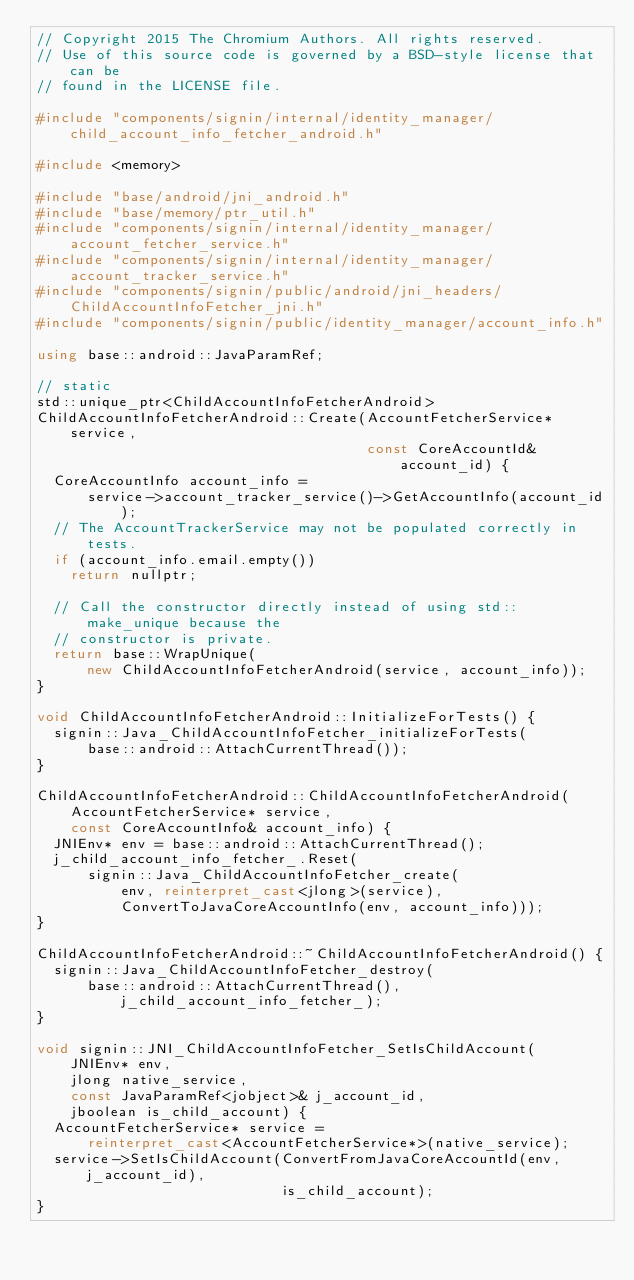<code> <loc_0><loc_0><loc_500><loc_500><_C++_>// Copyright 2015 The Chromium Authors. All rights reserved.
// Use of this source code is governed by a BSD-style license that can be
// found in the LICENSE file.

#include "components/signin/internal/identity_manager/child_account_info_fetcher_android.h"

#include <memory>

#include "base/android/jni_android.h"
#include "base/memory/ptr_util.h"
#include "components/signin/internal/identity_manager/account_fetcher_service.h"
#include "components/signin/internal/identity_manager/account_tracker_service.h"
#include "components/signin/public/android/jni_headers/ChildAccountInfoFetcher_jni.h"
#include "components/signin/public/identity_manager/account_info.h"

using base::android::JavaParamRef;

// static
std::unique_ptr<ChildAccountInfoFetcherAndroid>
ChildAccountInfoFetcherAndroid::Create(AccountFetcherService* service,
                                       const CoreAccountId& account_id) {
  CoreAccountInfo account_info =
      service->account_tracker_service()->GetAccountInfo(account_id);
  // The AccountTrackerService may not be populated correctly in tests.
  if (account_info.email.empty())
    return nullptr;

  // Call the constructor directly instead of using std::make_unique because the
  // constructor is private.
  return base::WrapUnique(
      new ChildAccountInfoFetcherAndroid(service, account_info));
}

void ChildAccountInfoFetcherAndroid::InitializeForTests() {
  signin::Java_ChildAccountInfoFetcher_initializeForTests(
      base::android::AttachCurrentThread());
}

ChildAccountInfoFetcherAndroid::ChildAccountInfoFetcherAndroid(
    AccountFetcherService* service,
    const CoreAccountInfo& account_info) {
  JNIEnv* env = base::android::AttachCurrentThread();
  j_child_account_info_fetcher_.Reset(
      signin::Java_ChildAccountInfoFetcher_create(
          env, reinterpret_cast<jlong>(service),
          ConvertToJavaCoreAccountInfo(env, account_info)));
}

ChildAccountInfoFetcherAndroid::~ChildAccountInfoFetcherAndroid() {
  signin::Java_ChildAccountInfoFetcher_destroy(
      base::android::AttachCurrentThread(), j_child_account_info_fetcher_);
}

void signin::JNI_ChildAccountInfoFetcher_SetIsChildAccount(
    JNIEnv* env,
    jlong native_service,
    const JavaParamRef<jobject>& j_account_id,
    jboolean is_child_account) {
  AccountFetcherService* service =
      reinterpret_cast<AccountFetcherService*>(native_service);
  service->SetIsChildAccount(ConvertFromJavaCoreAccountId(env, j_account_id),
                             is_child_account);
}
</code> 